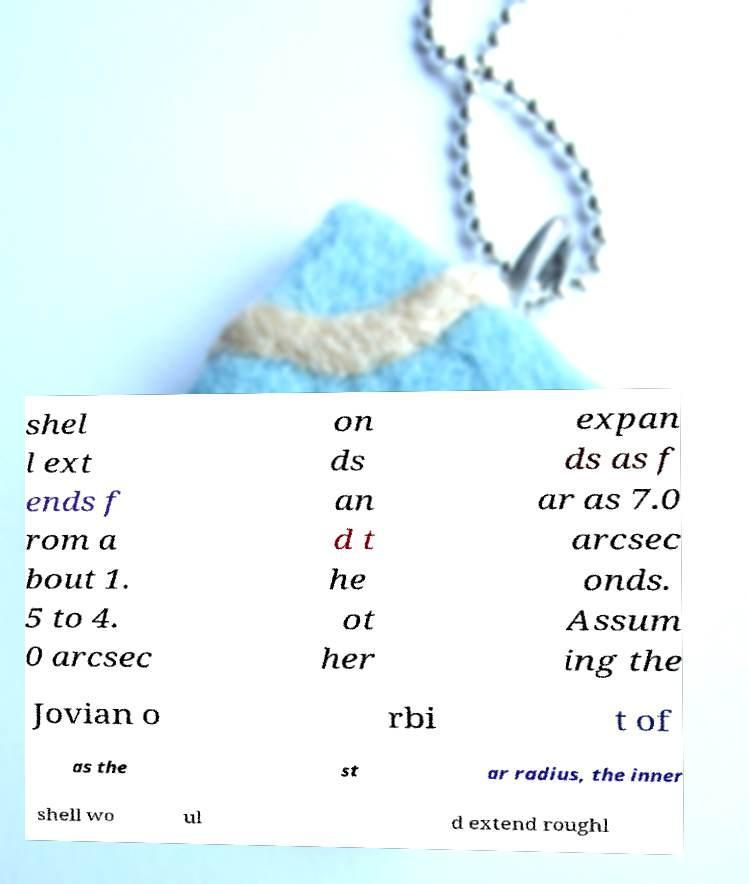Please identify and transcribe the text found in this image. shel l ext ends f rom a bout 1. 5 to 4. 0 arcsec on ds an d t he ot her expan ds as f ar as 7.0 arcsec onds. Assum ing the Jovian o rbi t of as the st ar radius, the inner shell wo ul d extend roughl 